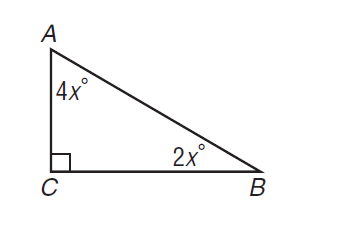Question: In the right triangle, what is A B if B C = 6?
Choices:
A. 2 \sqrt { 3 }
B. 4 \sqrt { 3 }
C. 6 \sqrt { 2 }
D. 12
Answer with the letter. Answer: B 